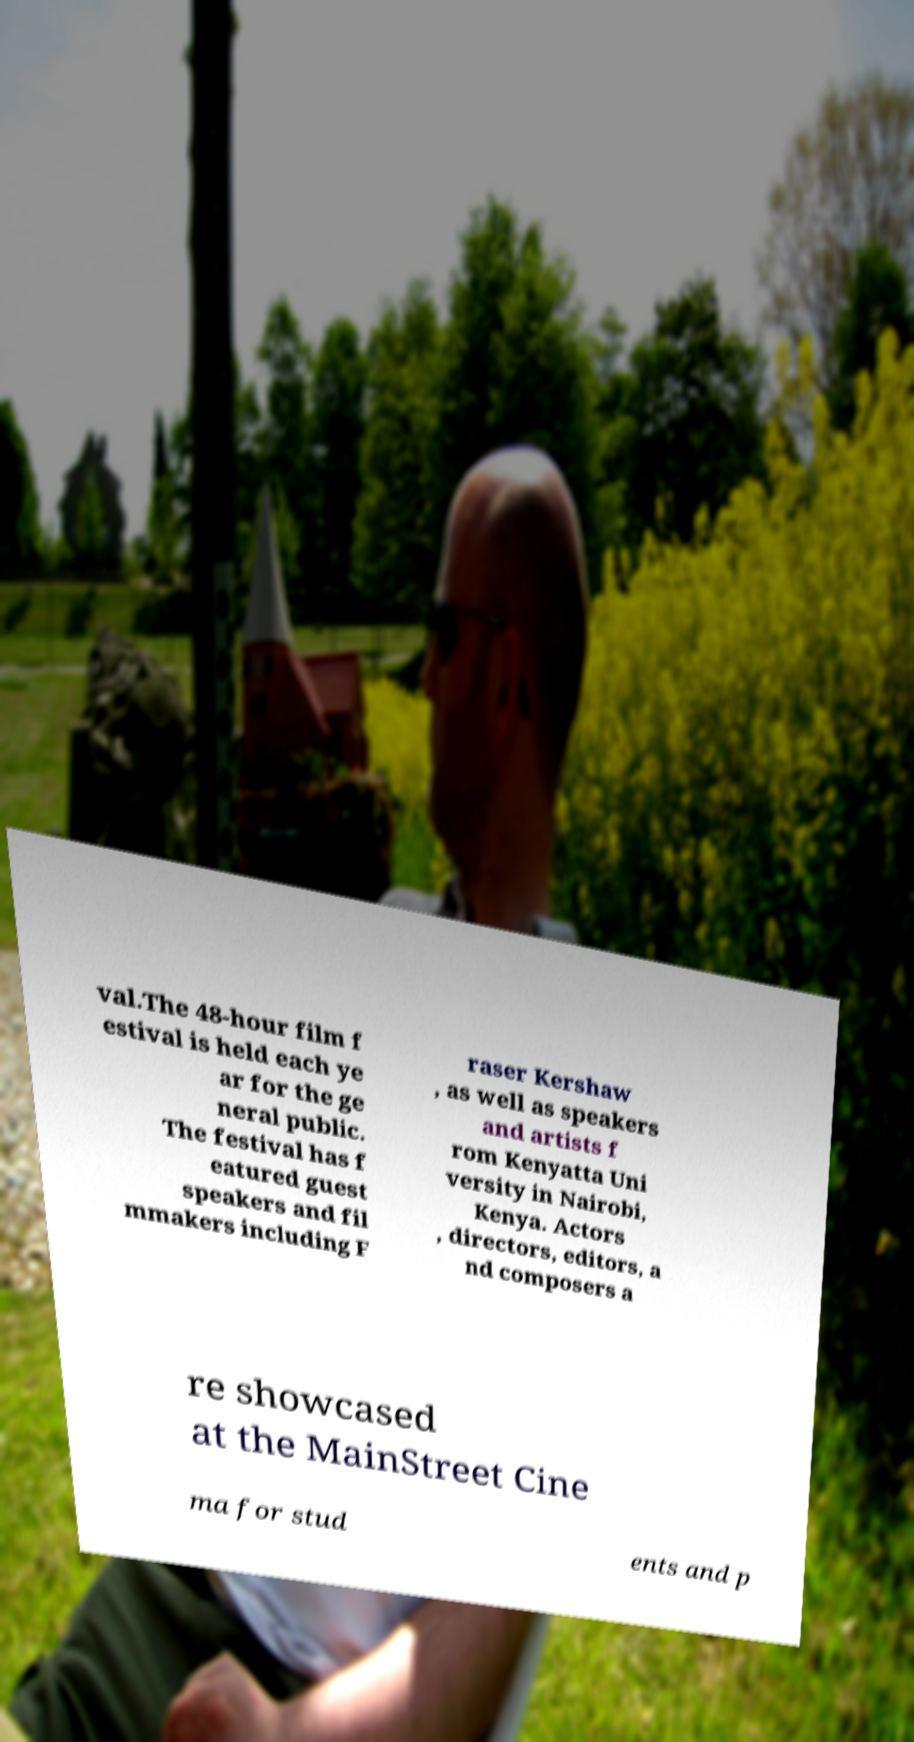What messages or text are displayed in this image? I need them in a readable, typed format. val.The 48-hour film f estival is held each ye ar for the ge neral public. The festival has f eatured guest speakers and fil mmakers including F raser Kershaw , as well as speakers and artists f rom Kenyatta Uni versity in Nairobi, Kenya. Actors , directors, editors, a nd composers a re showcased at the MainStreet Cine ma for stud ents and p 